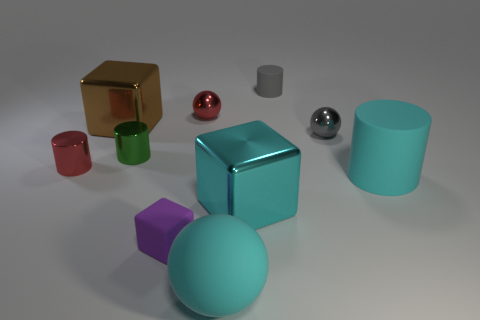What is the color of the matte object that is both to the right of the large cyan ball and to the left of the cyan cylinder? The matte object situated to the right of the large cyan ball and to the left of the cyan cylinder is gray, exhibiting a smooth, non-reflective surface that distinguishes it from the shinier objects nearby. 